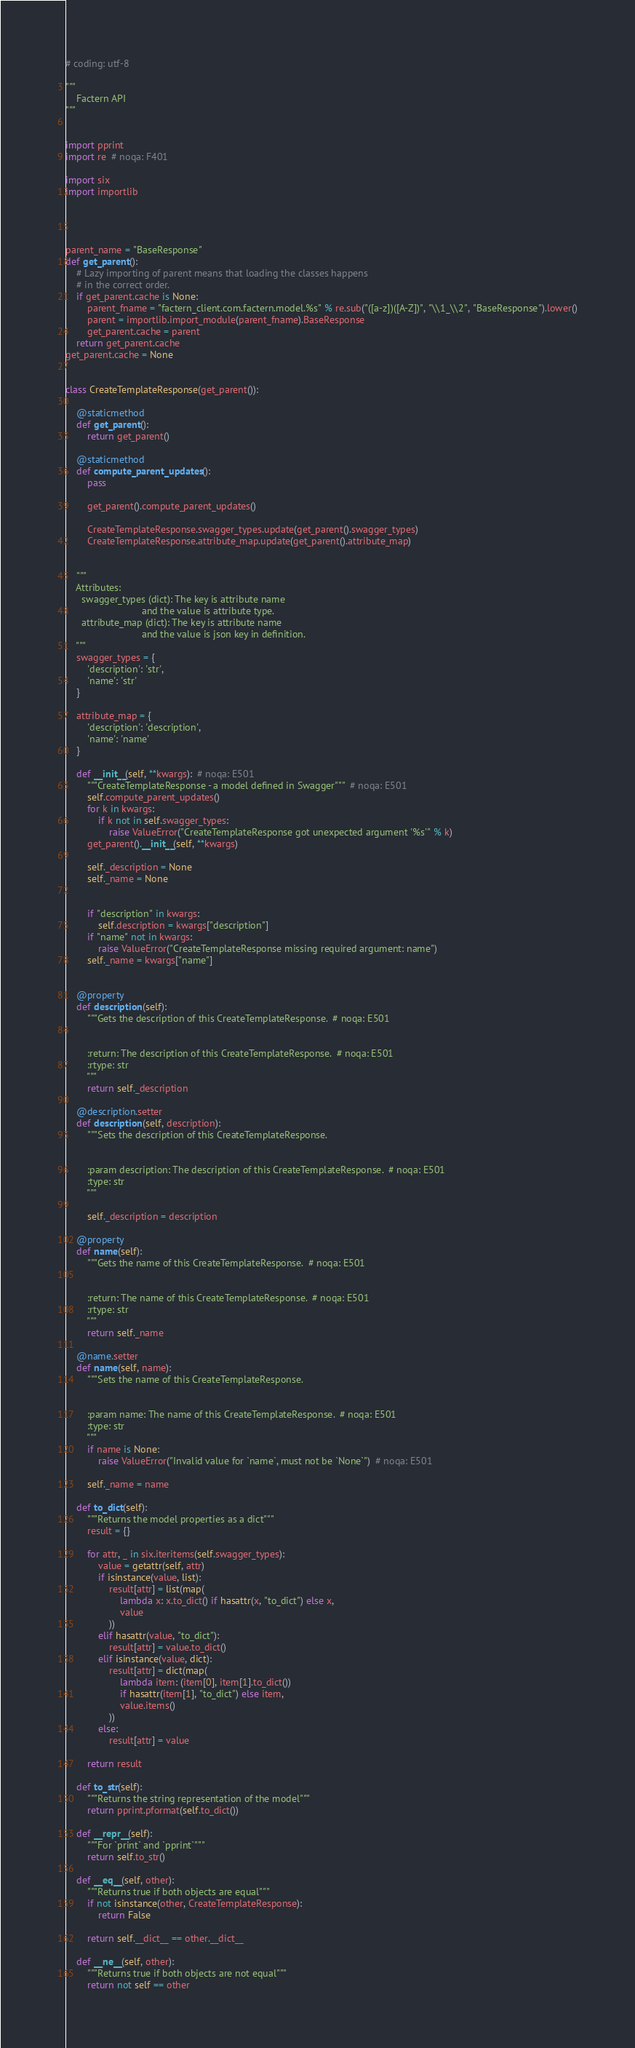Convert code to text. <code><loc_0><loc_0><loc_500><loc_500><_Python_># coding: utf-8

"""
    Factern API
"""


import pprint
import re  # noqa: F401

import six
import importlib




parent_name = "BaseResponse"
def get_parent():
    # Lazy importing of parent means that loading the classes happens
    # in the correct order.
    if get_parent.cache is None:
        parent_fname = "factern_client.com.factern.model.%s" % re.sub("([a-z])([A-Z])", "\\1_\\2", "BaseResponse").lower()
        parent = importlib.import_module(parent_fname).BaseResponse
        get_parent.cache = parent
    return get_parent.cache
get_parent.cache = None


class CreateTemplateResponse(get_parent()):

    @staticmethod
    def get_parent():
        return get_parent()

    @staticmethod
    def compute_parent_updates():
        pass

        get_parent().compute_parent_updates()

        CreateTemplateResponse.swagger_types.update(get_parent().swagger_types)
        CreateTemplateResponse.attribute_map.update(get_parent().attribute_map)


    """
    Attributes:
      swagger_types (dict): The key is attribute name
                            and the value is attribute type.
      attribute_map (dict): The key is attribute name
                            and the value is json key in definition.
    """
    swagger_types = {
        'description': 'str',
        'name': 'str'
    }

    attribute_map = {
        'description': 'description',
        'name': 'name'
    }

    def __init__(self, **kwargs):  # noqa: E501
        """CreateTemplateResponse - a model defined in Swagger"""  # noqa: E501
        self.compute_parent_updates()
        for k in kwargs:
            if k not in self.swagger_types:
                raise ValueError("CreateTemplateResponse got unexpected argument '%s'" % k)
        get_parent().__init__(self, **kwargs)

        self._description = None
        self._name = None


        if "description" in kwargs:
            self.description = kwargs["description"]
        if "name" not in kwargs:
            raise ValueError("CreateTemplateResponse missing required argument: name")
        self._name = kwargs["name"]


    @property
    def description(self):
        """Gets the description of this CreateTemplateResponse.  # noqa: E501


        :return: The description of this CreateTemplateResponse.  # noqa: E501
        :rtype: str
        """
        return self._description

    @description.setter
    def description(self, description):
        """Sets the description of this CreateTemplateResponse.


        :param description: The description of this CreateTemplateResponse.  # noqa: E501
        :type: str
        """

        self._description = description

    @property
    def name(self):
        """Gets the name of this CreateTemplateResponse.  # noqa: E501


        :return: The name of this CreateTemplateResponse.  # noqa: E501
        :rtype: str
        """
        return self._name

    @name.setter
    def name(self, name):
        """Sets the name of this CreateTemplateResponse.


        :param name: The name of this CreateTemplateResponse.  # noqa: E501
        :type: str
        """
        if name is None:
            raise ValueError("Invalid value for `name`, must not be `None`")  # noqa: E501

        self._name = name

    def to_dict(self):
        """Returns the model properties as a dict"""
        result = {}

        for attr, _ in six.iteritems(self.swagger_types):
            value = getattr(self, attr)
            if isinstance(value, list):
                result[attr] = list(map(
                    lambda x: x.to_dict() if hasattr(x, "to_dict") else x,
                    value
                ))
            elif hasattr(value, "to_dict"):
                result[attr] = value.to_dict()
            elif isinstance(value, dict):
                result[attr] = dict(map(
                    lambda item: (item[0], item[1].to_dict())
                    if hasattr(item[1], "to_dict") else item,
                    value.items()
                ))
            else:
                result[attr] = value

        return result

    def to_str(self):
        """Returns the string representation of the model"""
        return pprint.pformat(self.to_dict())

    def __repr__(self):
        """For `print` and `pprint`"""
        return self.to_str()

    def __eq__(self, other):
        """Returns true if both objects are equal"""
        if not isinstance(other, CreateTemplateResponse):
            return False

        return self.__dict__ == other.__dict__

    def __ne__(self, other):
        """Returns true if both objects are not equal"""
        return not self == other
</code> 